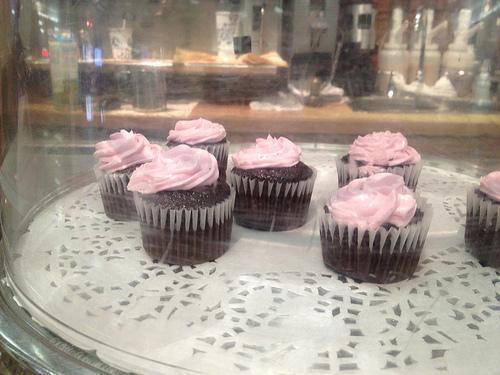How many have pink frosting?
Give a very brief answer. 7. How many cupcakes can be seen?
Give a very brief answer. 7. 